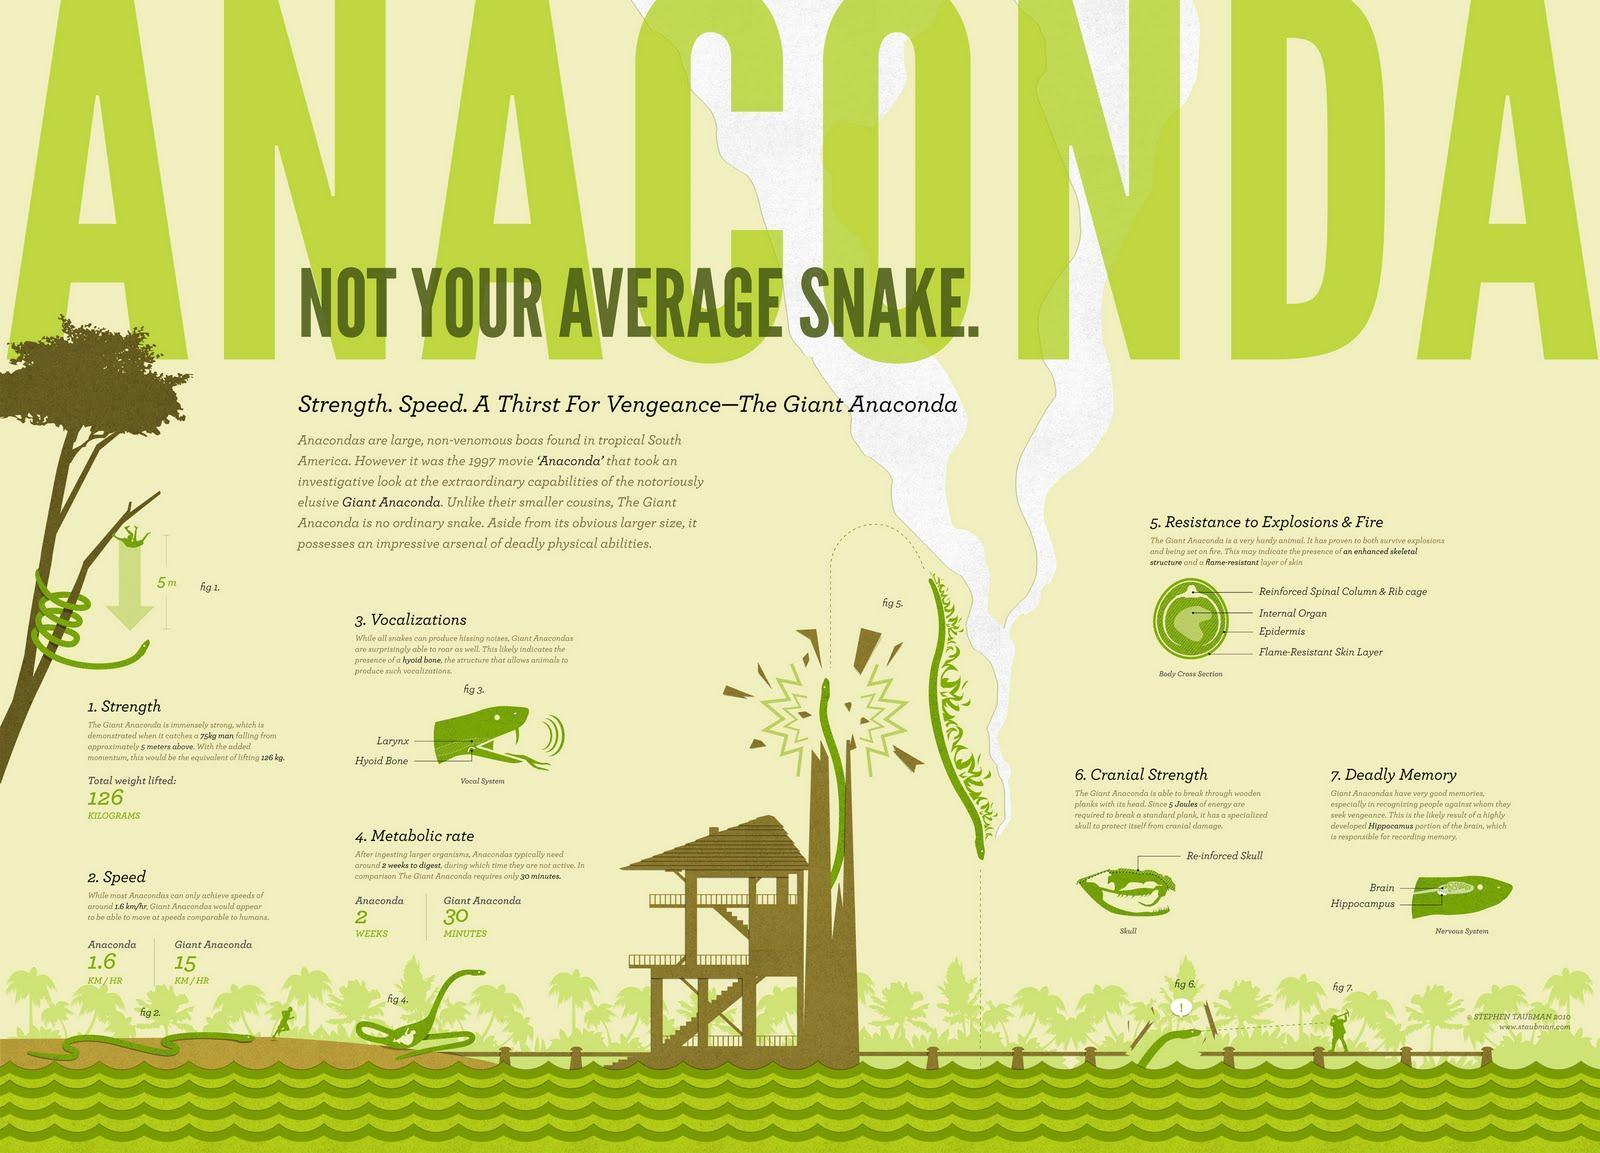In which regions of America are anacondas mostly found?
Answer the question with a short phrase. in tropical South America Which structure in giant anacondas helps to produce a roaring sound? Hyoid Bone What is the total weight lifted by a giant anaconda? 126 KILOGRAMS What is the metabolic rate of giant anacondas? 30 MINUTES Which component of the brain in giant anacondas are responsible for recognizing people? Hippocampus At what speed, the giant anaconda's can move? 15 KM/HR 